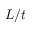<formula> <loc_0><loc_0><loc_500><loc_500>L / t</formula> 